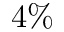Convert formula to latex. <formula><loc_0><loc_0><loc_500><loc_500>4 \%</formula> 